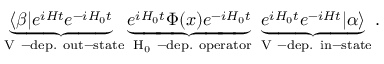Convert formula to latex. <formula><loc_0><loc_0><loc_500><loc_500>\underbrace { \langle \beta | e ^ { i H t } e ^ { - i H _ { 0 } t } } _ { V - d e p . o u t - s t a t e } \underbrace { e ^ { i H _ { 0 } t } \Phi ( x ) e ^ { - i H _ { 0 } t } } _ { H _ { 0 } - d e p . o p e r a t o r } \underbrace { e ^ { i H _ { 0 } t } e ^ { - i H t } | \alpha \rangle } _ { V - d e p . i n - s t a t e } .</formula> 